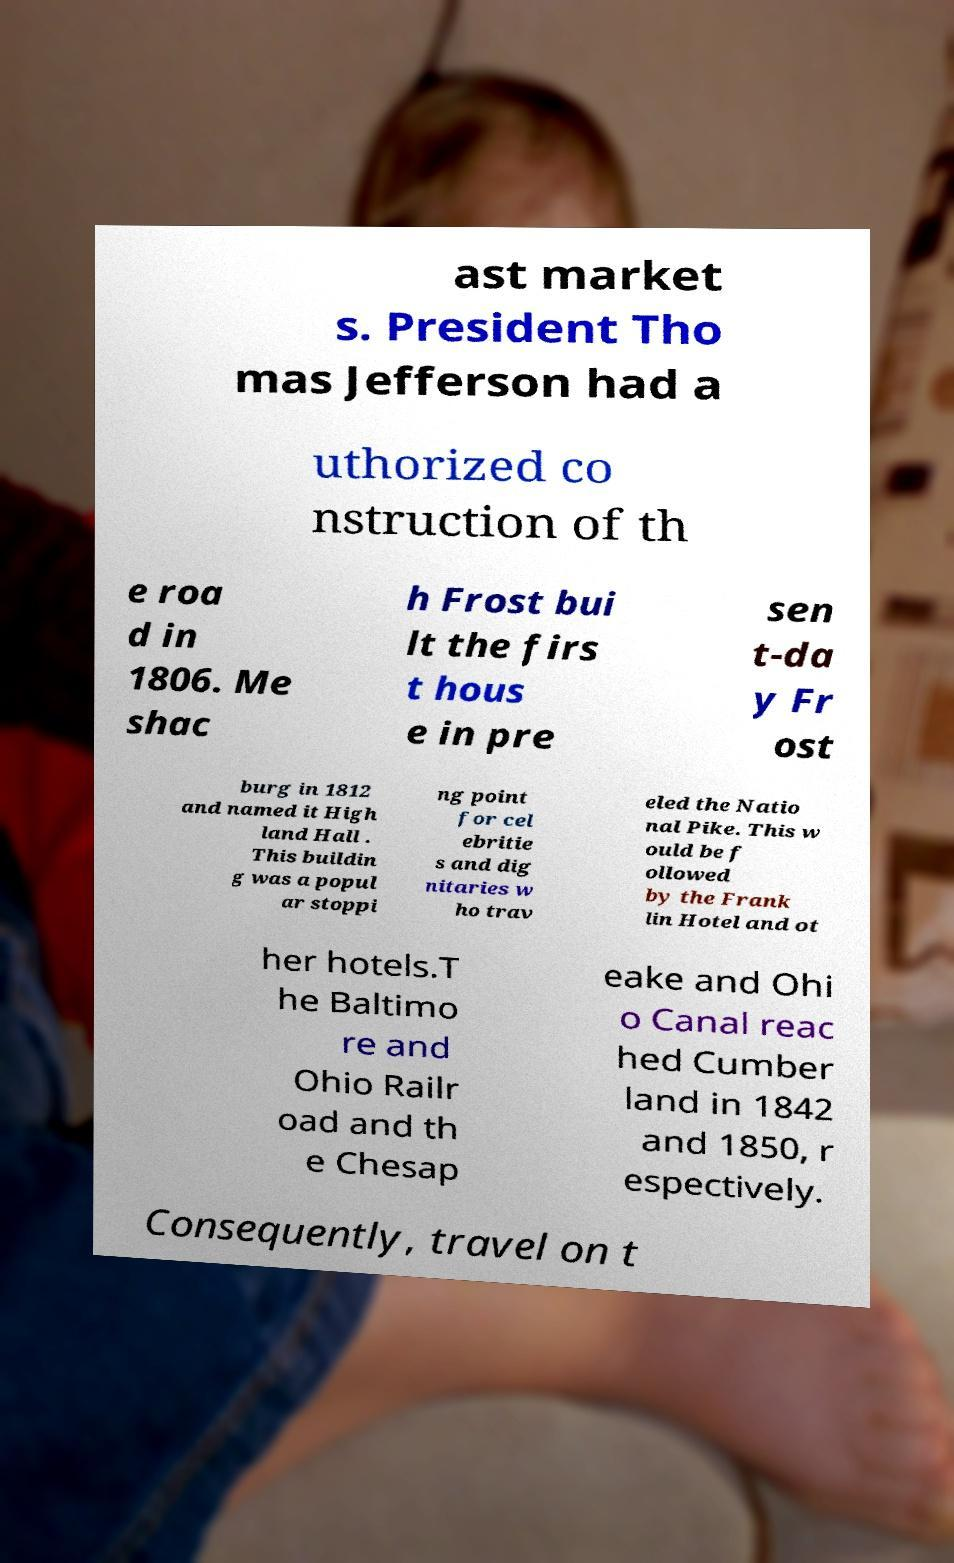Please read and relay the text visible in this image. What does it say? ast market s. President Tho mas Jefferson had a uthorized co nstruction of th e roa d in 1806. Me shac h Frost bui lt the firs t hous e in pre sen t-da y Fr ost burg in 1812 and named it High land Hall . This buildin g was a popul ar stoppi ng point for cel ebritie s and dig nitaries w ho trav eled the Natio nal Pike. This w ould be f ollowed by the Frank lin Hotel and ot her hotels.T he Baltimo re and Ohio Railr oad and th e Chesap eake and Ohi o Canal reac hed Cumber land in 1842 and 1850, r espectively. Consequently, travel on t 